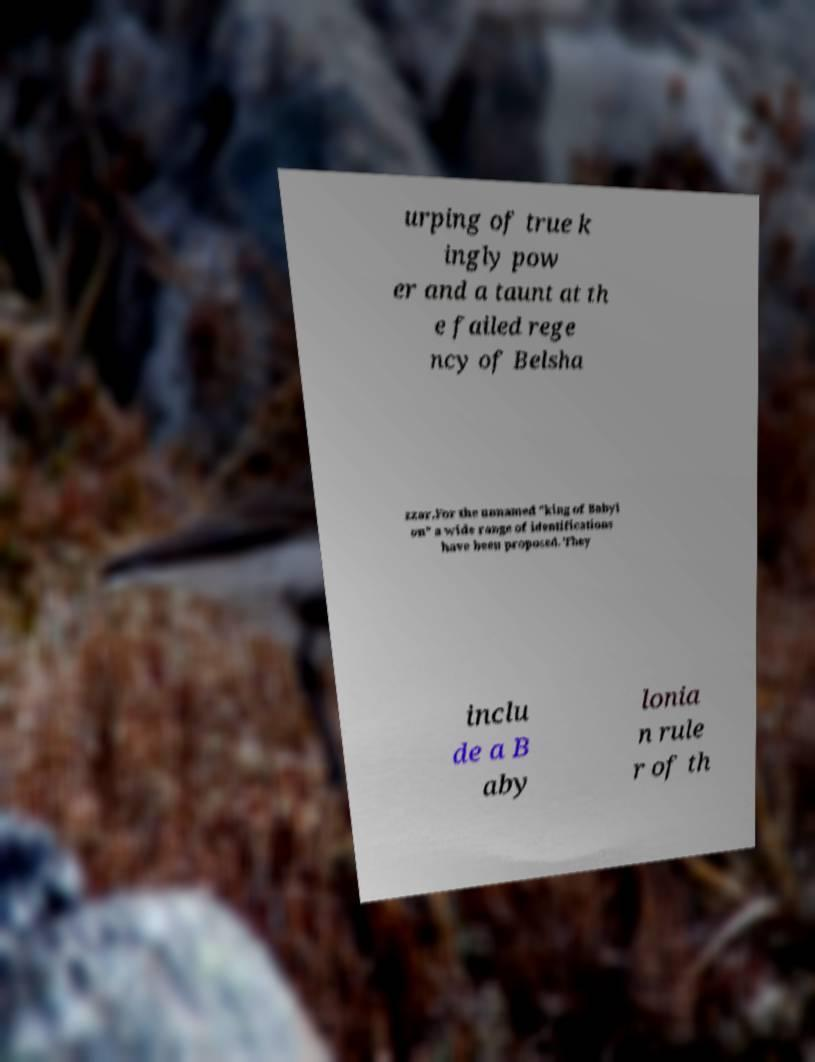Could you extract and type out the text from this image? urping of true k ingly pow er and a taunt at th e failed rege ncy of Belsha zzar.For the unnamed "king of Babyl on" a wide range of identifications have been proposed. They inclu de a B aby lonia n rule r of th 